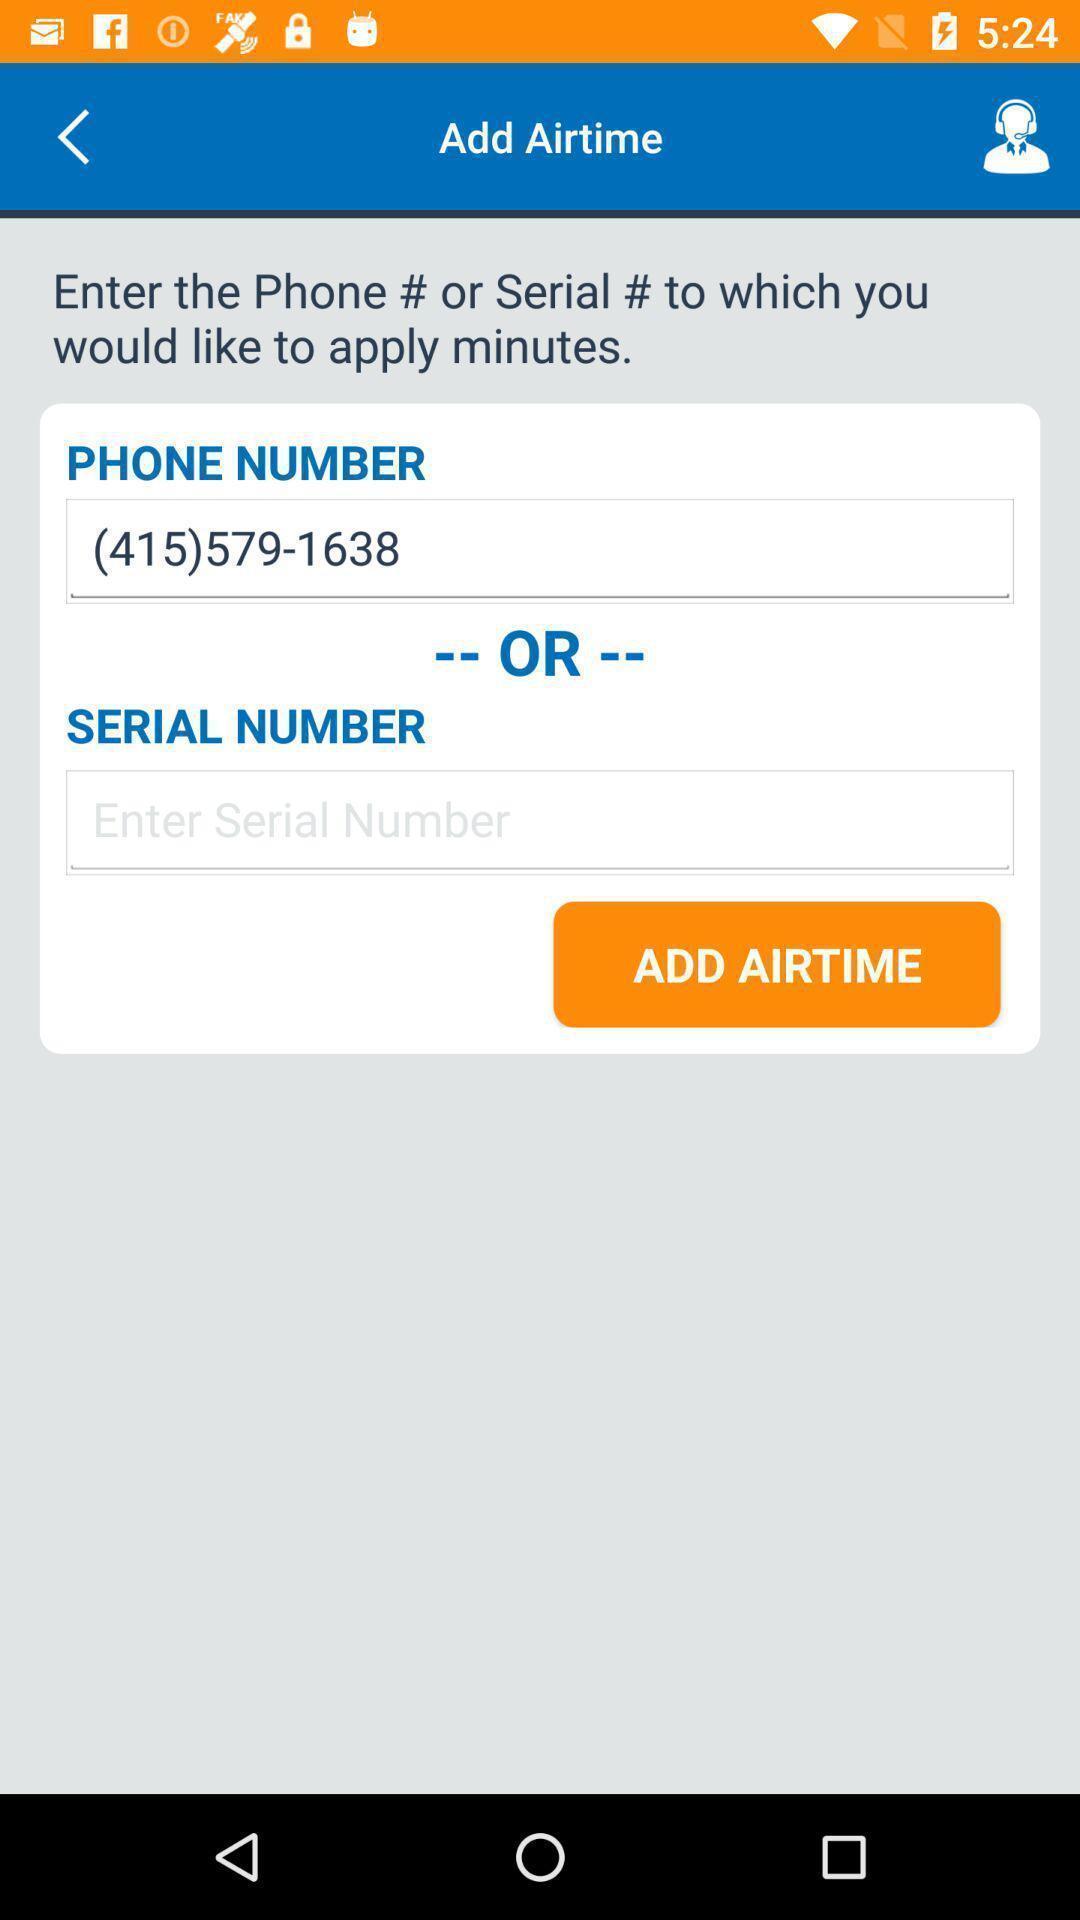Provide a detailed account of this screenshot. Page to add call time in the calling app. 